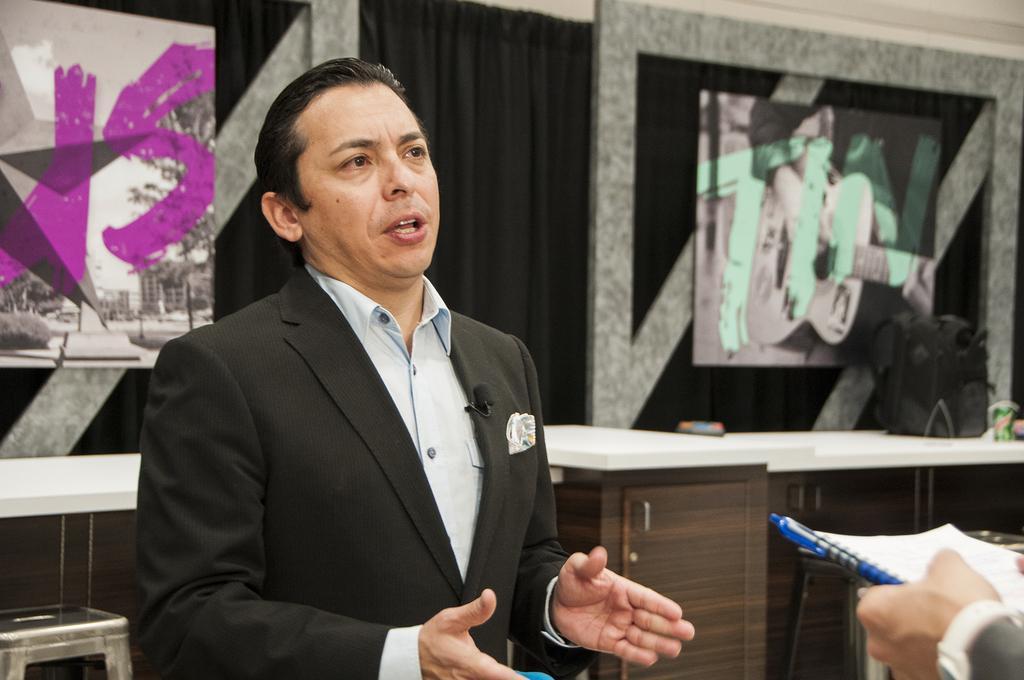Can you describe this image briefly? In the image we can see a man standing, wearing clothes and it looks like he is talking. Here we can see a microphone and we can even see the hand of a person holding a book. Here we can see posters, curtains and the image is slightly blurred. 